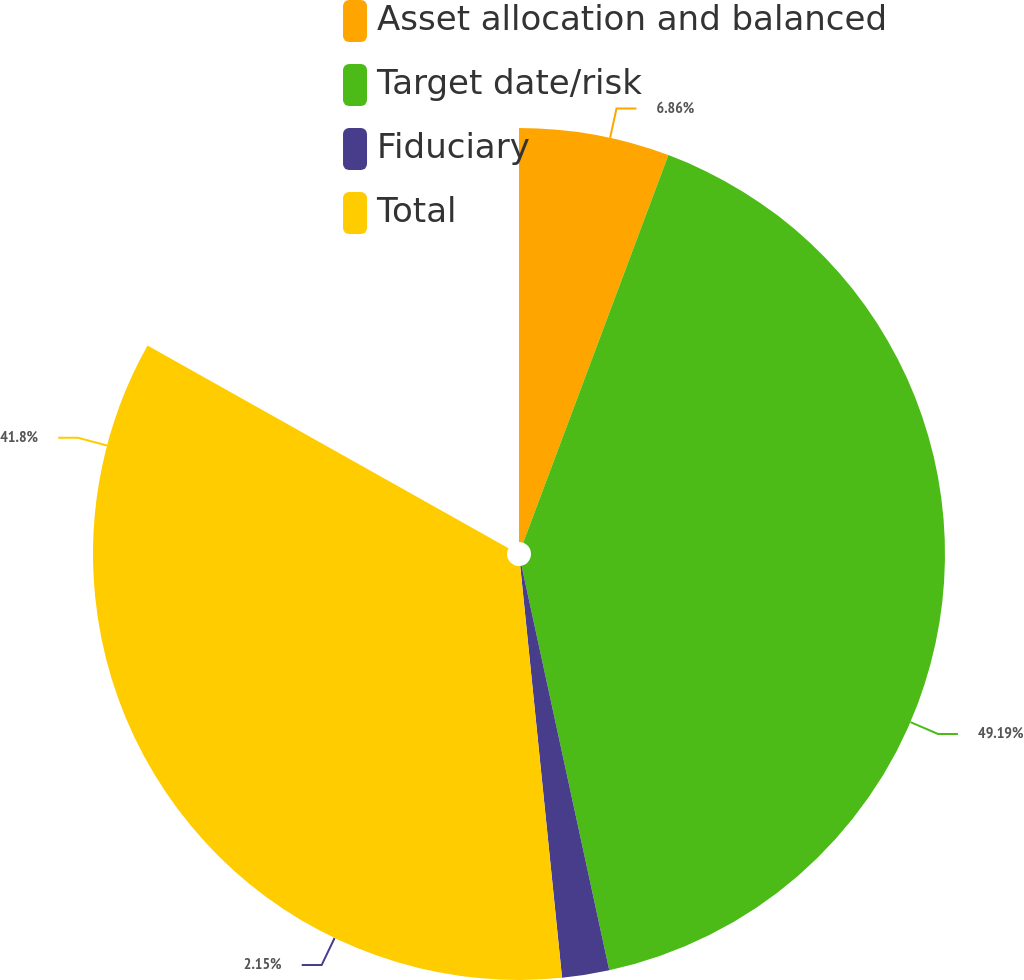Convert chart to OTSL. <chart><loc_0><loc_0><loc_500><loc_500><pie_chart><fcel>Asset allocation and balanced<fcel>Target date/risk<fcel>Fiduciary<fcel>Total<nl><fcel>6.86%<fcel>49.19%<fcel>2.15%<fcel>41.8%<nl></chart> 